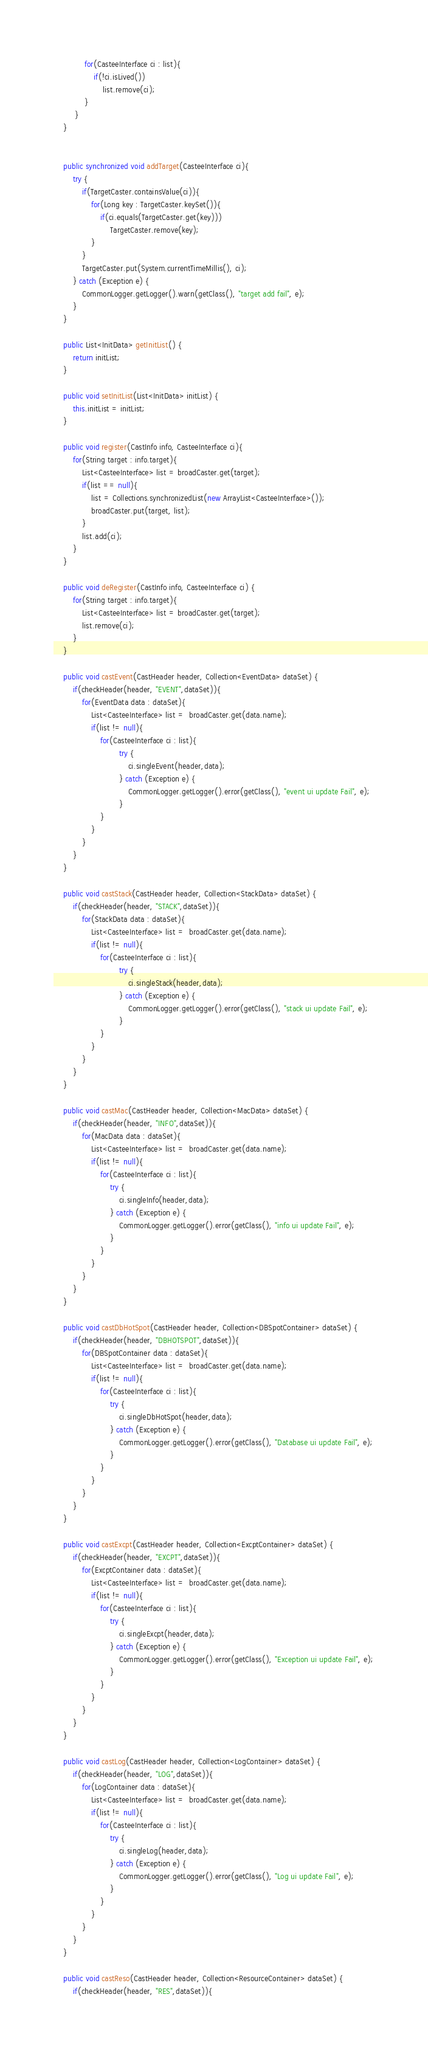Convert code to text. <code><loc_0><loc_0><loc_500><loc_500><_Java_>			 for(CasteeInterface ci : list){
				 if(!ci.isLived())
					 list.remove(ci);
			 }		 
		 }
	}


	public synchronized void addTarget(CasteeInterface ci){
		try {		
			if(TargetCaster.containsValue(ci)){
				for(Long key : TargetCaster.keySet()){
					if(ci.equals(TargetCaster.get(key)))
						TargetCaster.remove(key);
				}
			}
			TargetCaster.put(System.currentTimeMillis(), ci);
		} catch (Exception e) {
			CommonLogger.getLogger().warn(getClass(), "target add fail", e);
		}
	}
		
	public List<InitData> getInitList() {
		return initList;
	}

	public void setInitList(List<InitData> initList) {
		this.initList = initList;
	}
	
	public void register(CastInfo info, CasteeInterface ci){
		for(String target : info.target){
			List<CasteeInterface> list = broadCaster.get(target);
			if(list == null){
				list = Collections.synchronizedList(new ArrayList<CasteeInterface>());
				broadCaster.put(target, list);
			}
			list.add(ci);
		}
	}

	public void deRegister(CastInfo info, CasteeInterface ci) {
		for(String target : info.target){
			List<CasteeInterface> list = broadCaster.get(target);
			list.remove(ci);
		}
	}

	public void castEvent(CastHeader header, Collection<EventData> dataSet) {
		if(checkHeader(header, "EVENT",dataSet)){
			for(EventData data : dataSet){
				List<CasteeInterface> list =  broadCaster.get(data.name);
				if(list != null){
					for(CasteeInterface ci : list){
							try {
								ci.singleEvent(header,data);
							} catch (Exception e) {
								CommonLogger.getLogger().error(getClass(), "event ui update Fail", e);
							}
					}
				}
			}
		}
	}

	public void castStack(CastHeader header, Collection<StackData> dataSet) {
		if(checkHeader(header, "STACK",dataSet)){
			for(StackData data : dataSet){
				List<CasteeInterface> list =  broadCaster.get(data.name);
				if(list != null){
					for(CasteeInterface ci : list){
							try {
								ci.singleStack(header,data);
							} catch (Exception e) {
								CommonLogger.getLogger().error(getClass(), "stack ui update Fail", e);
							}
					}
				}
			}
		}
	}

	public void castMac(CastHeader header, Collection<MacData> dataSet) {
		if(checkHeader(header, "INFO",dataSet)){
			for(MacData data : dataSet){
				List<CasteeInterface> list =  broadCaster.get(data.name);
				if(list != null){
					for(CasteeInterface ci : list){
						try {
							ci.singleInfo(header,data);
						} catch (Exception e) {
							CommonLogger.getLogger().error(getClass(), "info ui update Fail", e);
						}
					}
				}
			}
		}
	}

	public void castDbHotSpot(CastHeader header, Collection<DBSpotContainer> dataSet) {
		if(checkHeader(header, "DBHOTSPOT",dataSet)){
			for(DBSpotContainer data : dataSet){
				List<CasteeInterface> list =  broadCaster.get(data.name);
				if(list != null){
					for(CasteeInterface ci : list){
						try {
							ci.singleDbHotSpot(header,data);
						} catch (Exception e) {
							CommonLogger.getLogger().error(getClass(), "Database ui update Fail", e);
						}
					}
				}
			}
		}
	}

	public void castExcpt(CastHeader header, Collection<ExcptContainer> dataSet) {
		if(checkHeader(header, "EXCPT",dataSet)){
			for(ExcptContainer data : dataSet){
				List<CasteeInterface> list =  broadCaster.get(data.name);
				if(list != null){
					for(CasteeInterface ci : list){
						try {
							ci.singleExcpt(header,data);
						} catch (Exception e) {
							CommonLogger.getLogger().error(getClass(), "Exception ui update Fail", e);
						}
					}
				}
			}
		}
	}

	public void castLog(CastHeader header, Collection<LogContainer> dataSet) {
		if(checkHeader(header, "LOG",dataSet)){
			for(LogContainer data : dataSet){
				List<CasteeInterface> list =  broadCaster.get(data.name);
				if(list != null){
					for(CasteeInterface ci : list){
						try {
							ci.singleLog(header,data);
						} catch (Exception e) {
							CommonLogger.getLogger().error(getClass(), "Log ui update Fail", e);
						}
					}
				}
			}
		}
	}

	public void castReso(CastHeader header, Collection<ResourceContainer> dataSet) {
		if(checkHeader(header, "RES",dataSet)){</code> 